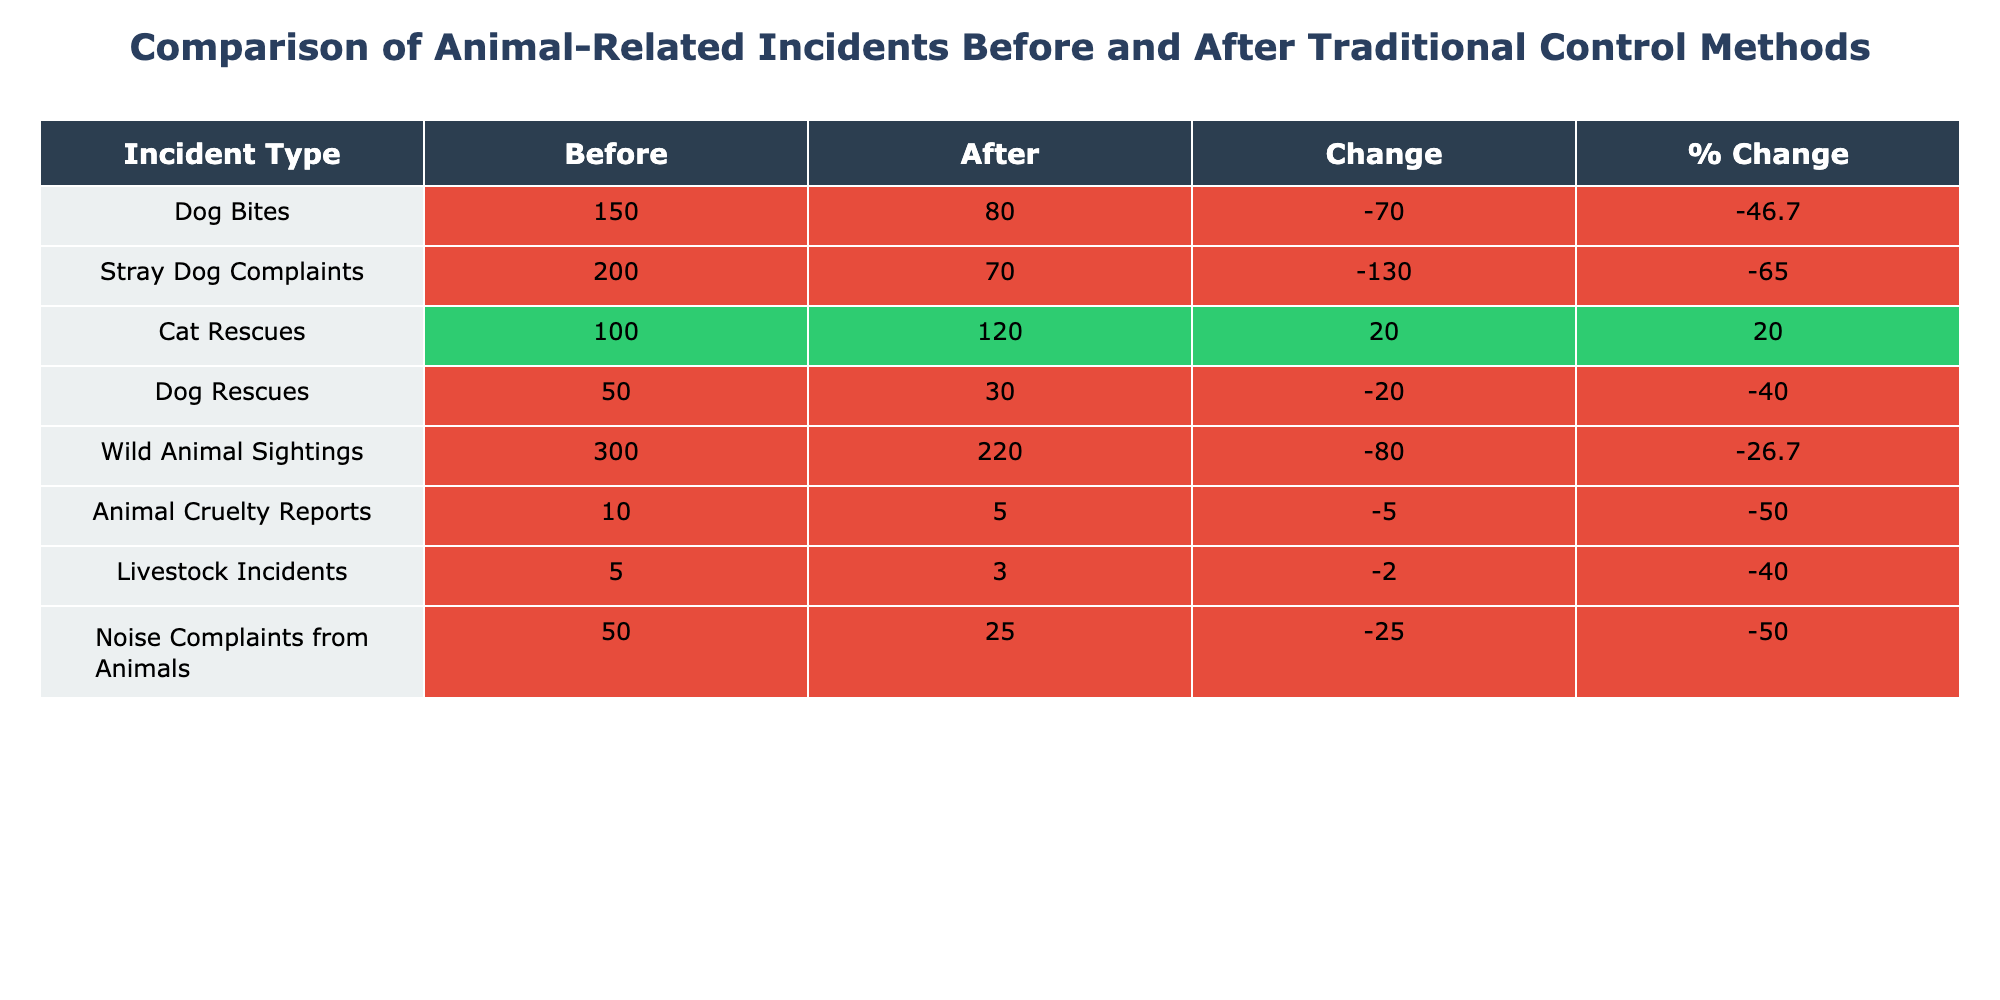What was the total number of reported dog-related incidents before the implementation of traditional control methods? The table shows two types of dog-related incidents: Dog Bites and Dog Rescues. Adding these together, we have 150 + 50 = 200.
Answer: 200 What is the percentage decrease in Dog Bites after implementing traditional control methods? The number of Dog Bites before was 150, and after it was 80. The decrease is 150 - 80 = 70. To find the percentage decrease, we use (70 / 150) * 100 = 46.7%.
Answer: 46.7% Did the number of Cat Rescues increase or decrease after the implementation of traditional control methods? The table indicates that Cat Rescues increased from 100 to 120. Since the number after is higher than before, it shows an increase.
Answer: Yes Which incident type had the highest total number of reported incidents before traditional control methods? Looking at the values in the 'Before' column, Stray Dog Complaints has the highest at 200, compared to other incident types.
Answer: Stray Dog Complaints Calculate the total number of animal-related incidents reported after the implementation of traditional control methods. By summing all the incidents in the 'After' column, we have 80 (Dog Bites) + 70 (Stray Dog Complaints) + 120 (Cat Rescues) + 30 (Dog Rescues) + 220 (Wild Animal Sightings) + 5 (Animal Cruelty Reports) + 3 (Livestock Incidents) + 25 (Noise Complaints) = 573.
Answer: 573 Was there a reduction in the number of reported Noise Complaints from Animals after implementing traditional control methods? The number of Noise Complaints decreased from 50 to 25. Since the number after is lower, it confirms a reduction.
Answer: Yes What is the total change in Wild Animal Sightings after the implementation of traditional control methods? The number of Wild Animal Sightings decreased from 300 to 220, which is a change of 300 - 220 = 80.
Answer: 80 Are there more Cat Rescues than Dog Rescues after implementing traditional control methods? After implementation, Cat Rescues are reported at 120 while Dog Rescues are at 30. Since 120 is greater than 30, it indicates more Cat Rescues.
Answer: Yes What is the total number of incidents reported across all categories before implementing traditional control methods? We sum the incidents in the 'Before' column: 150 (Dog Bites) + 200 (Stray Dog Complaints) + 100 (Cat Rescues) + 50 (Dog Rescues) + 300 (Wild Animal Sightings) + 10 (Animal Cruelty Reports) + 5 (Livestock Incidents) + 50 (Noise Complaints) = 865.
Answer: 865 